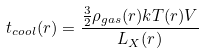<formula> <loc_0><loc_0><loc_500><loc_500>t _ { c o o l } ( r ) = \frac { \frac { 3 } { 2 } \rho _ { g a s } ( r ) k T ( r ) V } { L _ { X } ( r ) }</formula> 